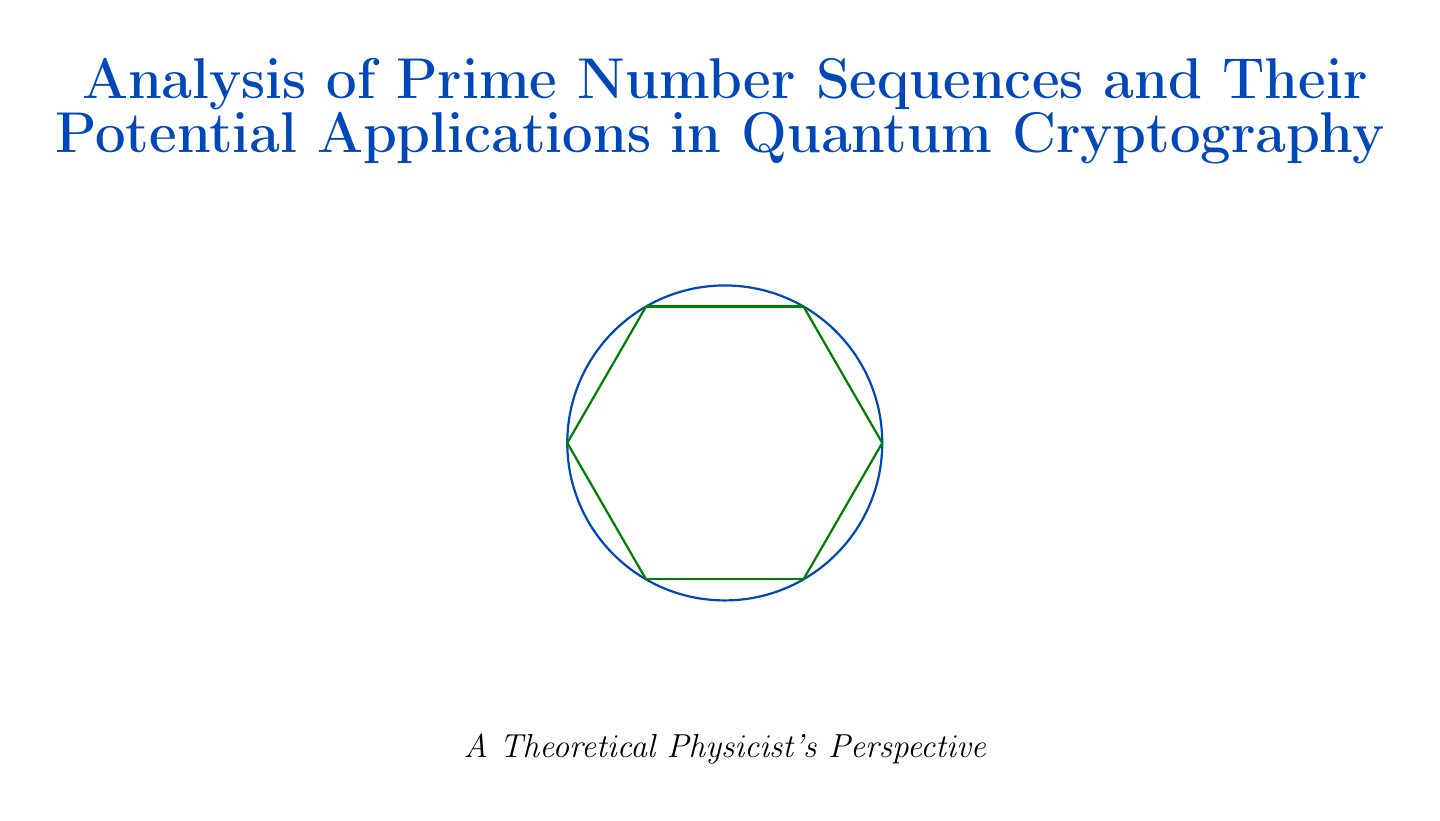what is the title of the report? The title is found at the beginning of the document and sets the main theme, focusing on prime number sequences and their applications in quantum cryptography.
Answer: Analysis of Prime Number Sequences and Their Potential Applications in Quantum Cryptography who discovered the Ulam spiral? This information is located in the subsection discussing prime number patterns, detailing the origin of the spiral and its significance.
Answer: Stanislaw Ulam what year was Shor's algorithm published? The publication year of Shor's algorithm can be found in the references section.
Answer: 1997 what is the improvement percentage in key generation rate demonstrated in the experiments? The document mentions this improvement in the experimental results section, highlighting the impact of using prime number sequences.
Answer: 15% which prime number form is utilized in quantum random number generators? This detail is explicitly described in the subsection about Mersenne primes, indicating their specific mathematical representation.
Answer: 2^p - 1 what do Sophie Germain primes satisfy? The properties of Sophie Germain primes are stated in the subsection, explaining their unique relationships to other prime numbers.
Answer: both p and 2p + 1 are prime what potential challenge is mentioned regarding prime number generation in quantum systems? The challenges section discusses specific issues related to prime number generation, addressing necessary improvements and focus areas for future research.
Answer: efficiently generating and verifying large prime numbers what fundamental concept in quantum mechanics is leveraged for secure communication? The document refers to this concept in the context of entanglement-based cryptography, identifying its importance in the security mechanisms.
Answer: Entanglement 